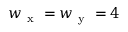Convert formula to latex. <formula><loc_0><loc_0><loc_500><loc_500>w _ { x } = w _ { y } = 4</formula> 